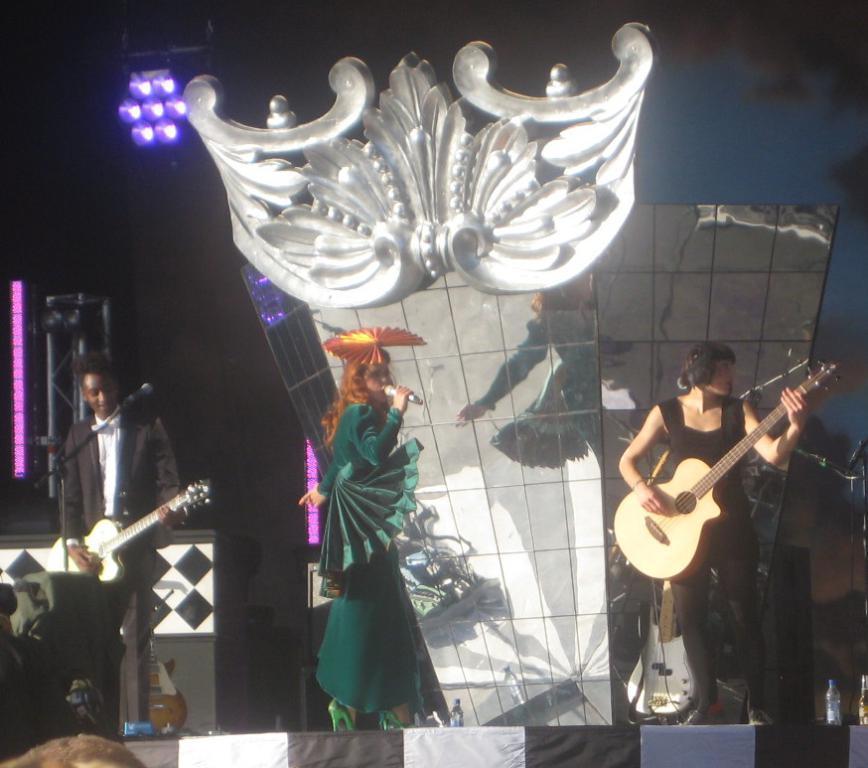Describe this image in one or two sentences. In this image there are three persons standing on the stage and playing musical instrument. At the background there is frame and a light. 